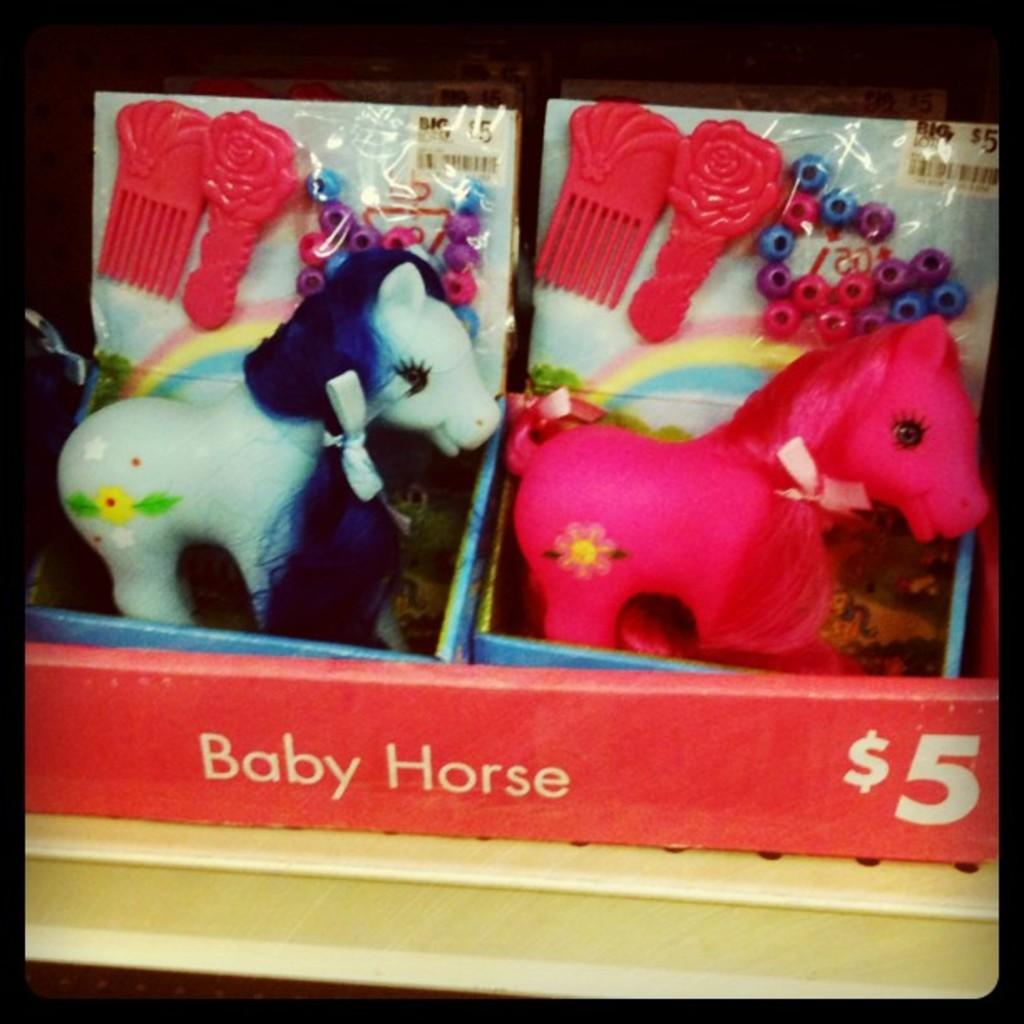What type of objects can be seen in the image? There are toys in the image. What type of education system is being taught in the town depicted in the image? There is no town or education system depicted in the image; it only features toys. 